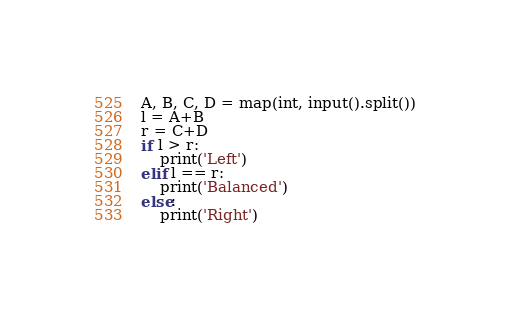Convert code to text. <code><loc_0><loc_0><loc_500><loc_500><_Python_>A, B, C, D = map(int, input().split())
l = A+B
r = C+D
if l > r:
    print('Left')
elif l == r:
    print('Balanced')
else:
    print('Right')</code> 